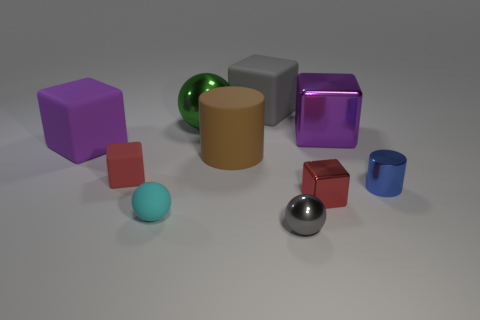The big metal cube has what color?
Your answer should be compact. Purple. There is a red cube behind the small red metallic object; are there any purple metallic cubes that are behind it?
Give a very brief answer. Yes. What is the shape of the large purple object that is to the right of the red object that is on the right side of the large brown matte cylinder?
Your answer should be very brief. Cube. Are there fewer purple balls than large things?
Give a very brief answer. Yes. Are the brown cylinder and the large green ball made of the same material?
Your response must be concise. No. There is a small object that is behind the cyan matte object and on the left side of the green metal thing; what is its color?
Your answer should be compact. Red. Are there any green shiny cubes that have the same size as the brown object?
Your response must be concise. No. There is a purple object in front of the purple block that is right of the gray metallic ball; how big is it?
Provide a short and direct response. Large. Are there fewer metallic objects that are in front of the small cyan rubber thing than purple matte objects?
Ensure brevity in your answer.  No. Is the color of the small metal block the same as the tiny matte block?
Provide a succinct answer. Yes. 